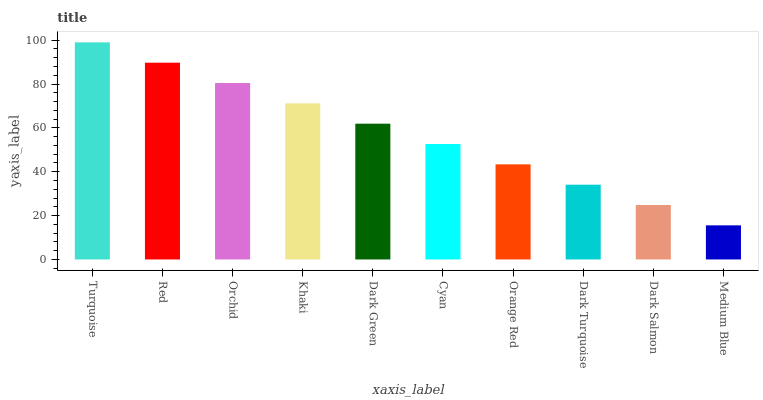Is Medium Blue the minimum?
Answer yes or no. Yes. Is Turquoise the maximum?
Answer yes or no. Yes. Is Red the minimum?
Answer yes or no. No. Is Red the maximum?
Answer yes or no. No. Is Turquoise greater than Red?
Answer yes or no. Yes. Is Red less than Turquoise?
Answer yes or no. Yes. Is Red greater than Turquoise?
Answer yes or no. No. Is Turquoise less than Red?
Answer yes or no. No. Is Dark Green the high median?
Answer yes or no. Yes. Is Cyan the low median?
Answer yes or no. Yes. Is Cyan the high median?
Answer yes or no. No. Is Medium Blue the low median?
Answer yes or no. No. 